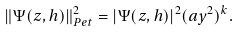<formula> <loc_0><loc_0><loc_500><loc_500>\| \Psi ( z , h ) \| _ { P e t } ^ { 2 } = | \Psi ( z , h ) | ^ { 2 } ( a y ^ { 2 } ) ^ { k } .</formula> 